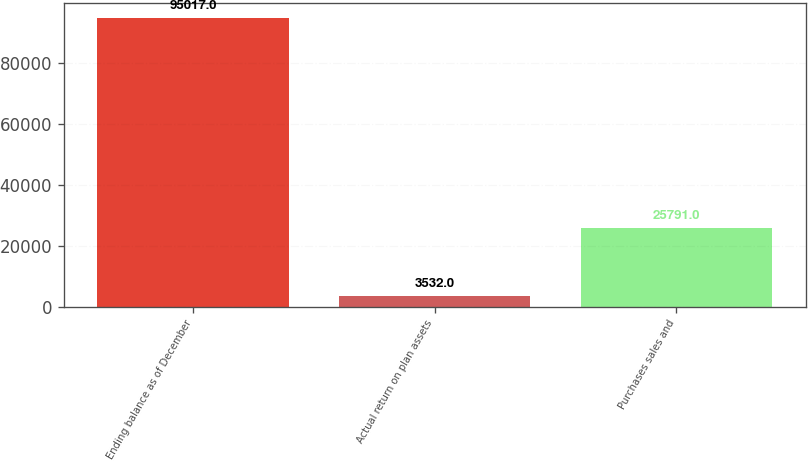<chart> <loc_0><loc_0><loc_500><loc_500><bar_chart><fcel>Ending balance as of December<fcel>Actual return on plan assets<fcel>Purchases sales and<nl><fcel>95017<fcel>3532<fcel>25791<nl></chart> 